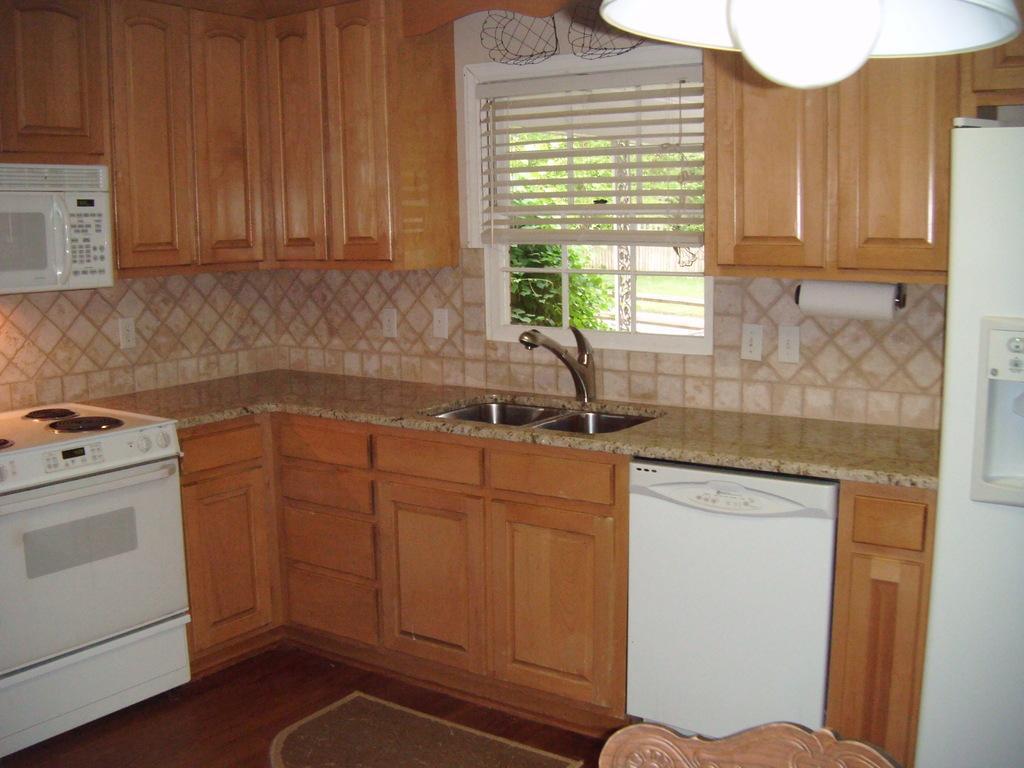Could you give a brief overview of what you see in this image? In this picture we can see tap, sink and a machine on the left side. We can see a few wooden cupboards from left to right. There is a tissue on a rod. We can see a few switch boards on the wall. We can see some trees in the background. 